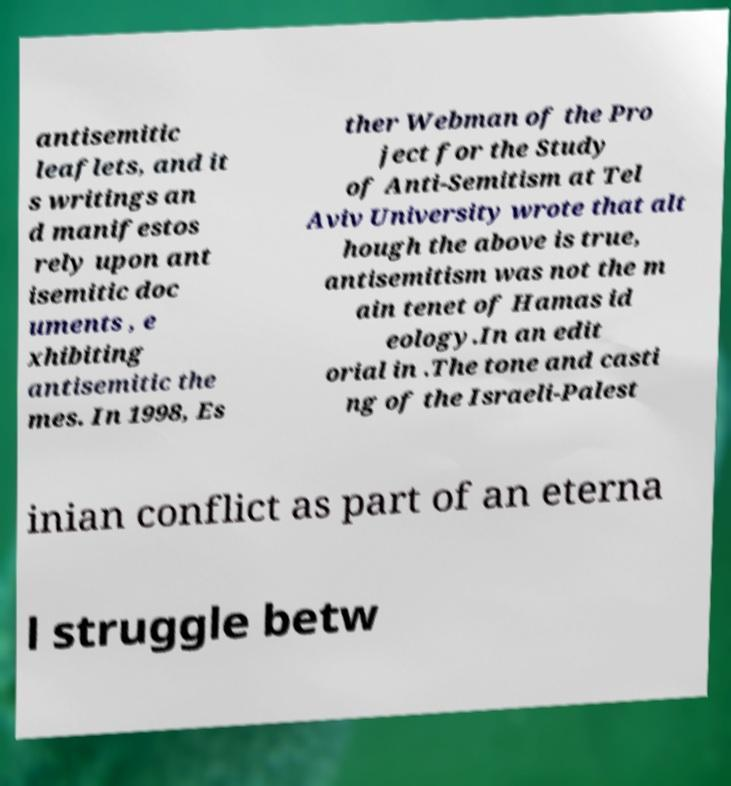What messages or text are displayed in this image? I need them in a readable, typed format. antisemitic leaflets, and it s writings an d manifestos rely upon ant isemitic doc uments , e xhibiting antisemitic the mes. In 1998, Es ther Webman of the Pro ject for the Study of Anti-Semitism at Tel Aviv University wrote that alt hough the above is true, antisemitism was not the m ain tenet of Hamas id eology.In an edit orial in .The tone and casti ng of the Israeli-Palest inian conflict as part of an eterna l struggle betw 